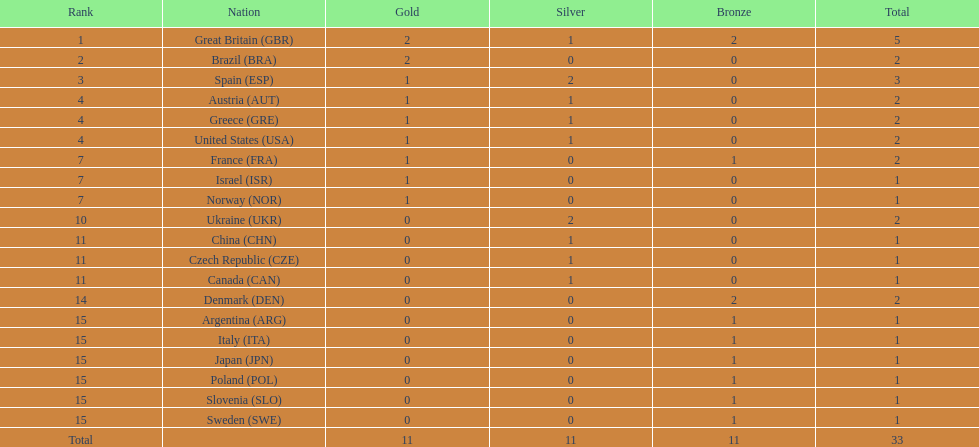Who has secured more gold medals in comparison to spain? Great Britain (GBR), Brazil (BRA). 